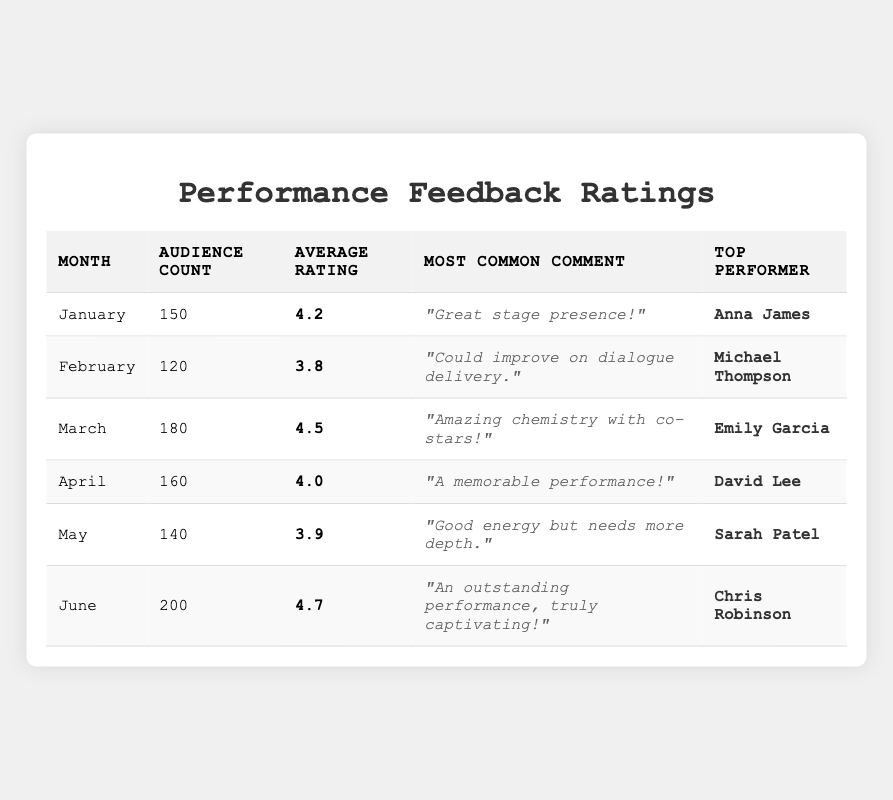What's the highest average rating? The highest average rating in the table is found in June, where the average rating is 4.7.
Answer: 4.7 Which month had the most audience count? June had the highest audience count with 200 people attending.
Answer: June What was the most common comment in February? The most common comment for February was "Could improve on dialogue delivery."
Answer: "Could improve on dialogue delivery." How many total audience members were there over the six months? To find the total audience members, add the audience counts: 150 + 120 + 180 + 160 + 140 + 200 = 1,050.
Answer: 1,050 Which performer received the highest average rating, and in which month did that occur? The highest average rating was 4.7 attributed to Chris Robinson in June.
Answer: Chris Robinson, June Did any month receive a rating above 4.5? Yes, March and June both received ratings above 4.5.
Answer: Yes What is the average rating across all six months? Calculate the average rating by adding the ratings (4.2 + 3.8 + 4.5 + 4.0 + 3.9 + 4.7) and dividing by 6. This sums to 25.1, then divide: 25.1 / 6 = 4.18.
Answer: 4.18 In which month did Sarah Patel perform, and what was her average rating? Sarah Patel performed in May, where she received an average rating of 3.9.
Answer: May, 3.9 Which performer had the most favorable feedback in terms of comments and ratings? The most favorable feedback was for Chris Robinson, with an outstanding performance noted, and an average rating of 4.7, the highest of all months.
Answer: Chris Robinson Was there any month where the top performer did not have a rating of at least 4.0? Yes, February's top performer, Michael Thompson, had a rating of 3.8, which is below 4.0.
Answer: Yes Which month had the most positive feedback, based on the most common comment? June had the most positive feedback, as the most common comment was "An outstanding performance, truly captivating!"
Answer: June 